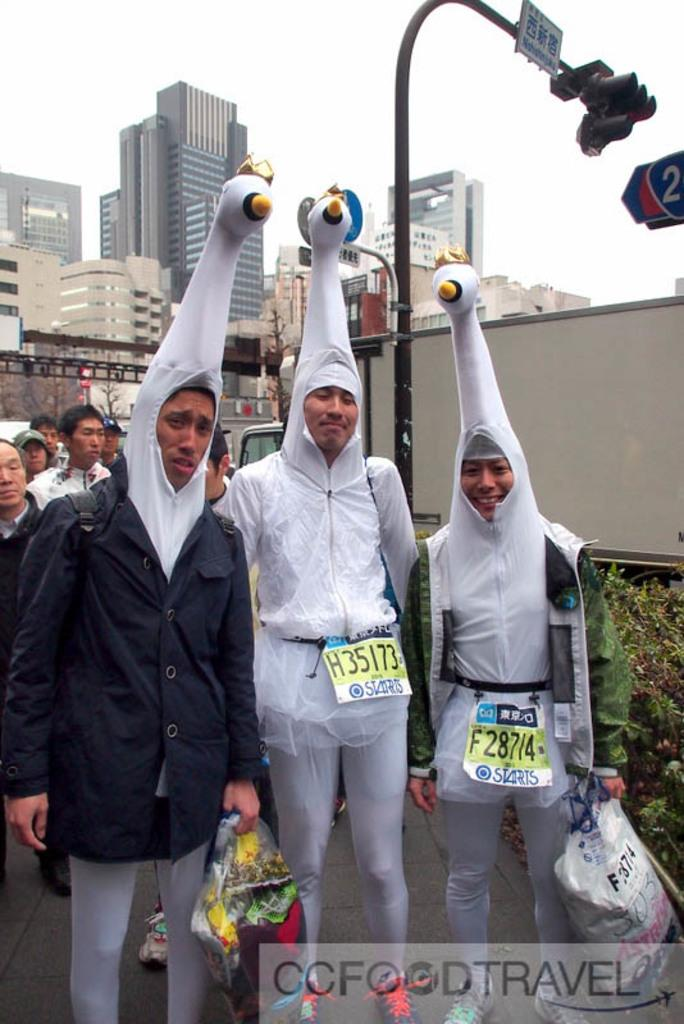How many people are in the image? There are three people in the image. What are the three people wearing on their heads? The three people are wearing something that resembles a bird on their heads. Can you describe the background of the image? In the background of the image, there are other people, plants, buildings, and other unspecified things. What language are the people speaking in the image? The provided facts do not mention anything about the language being spoken in the image. Where is the train station located in the image? There is no train station present in the image. 